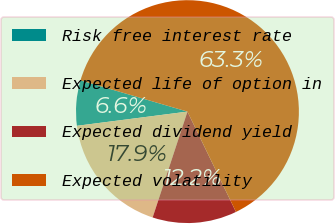Convert chart to OTSL. <chart><loc_0><loc_0><loc_500><loc_500><pie_chart><fcel>Risk free interest rate<fcel>Expected life of option in<fcel>Expected dividend yield<fcel>Expected volatility<nl><fcel>6.56%<fcel>17.91%<fcel>12.23%<fcel>63.31%<nl></chart> 